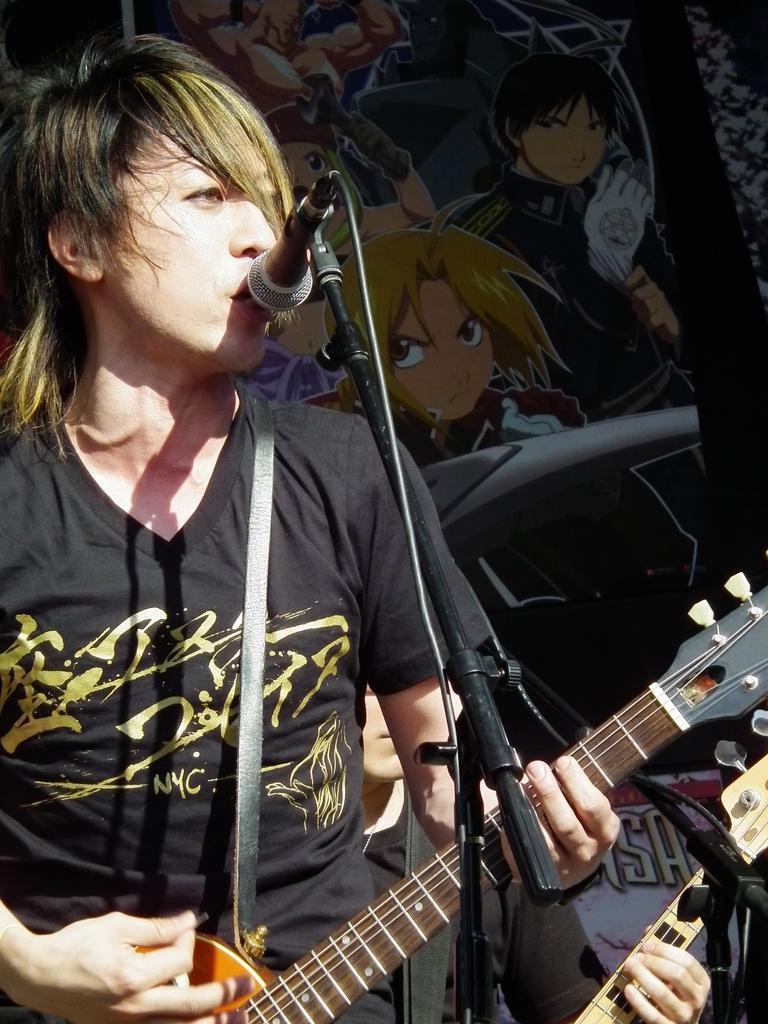Could you give a brief overview of what you see in this image? There is a man standing with guitar in front of microphone. 